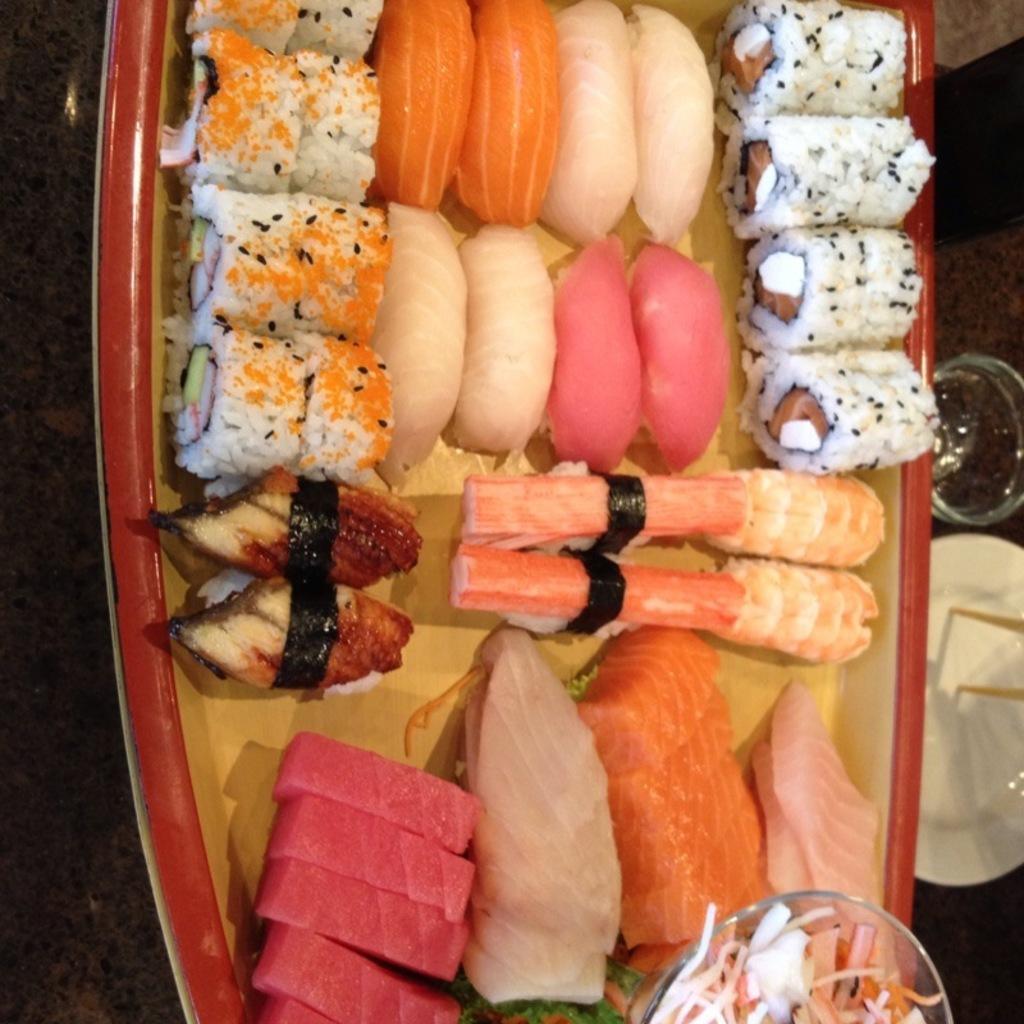Describe this image in one or two sentences. Here in this picture we can see some food items present in a plate, which is present on a table and beside that we can see a plate and a glass present. 